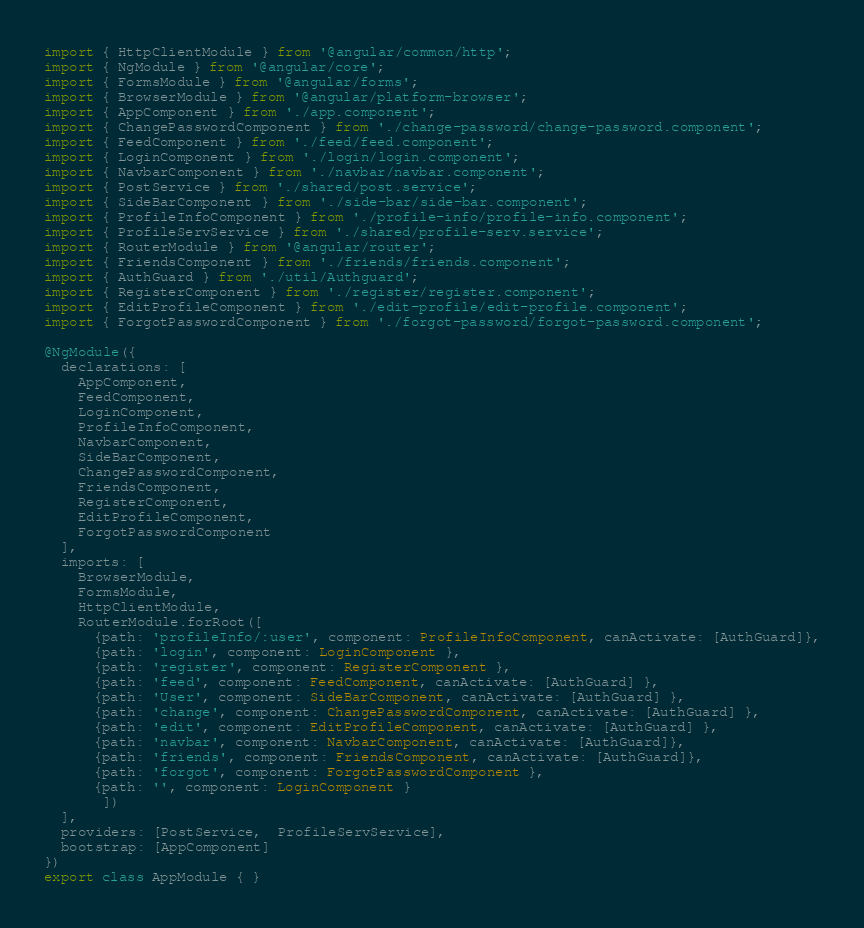<code> <loc_0><loc_0><loc_500><loc_500><_TypeScript_>import { HttpClientModule } from '@angular/common/http';
import { NgModule } from '@angular/core';
import { FormsModule } from '@angular/forms';
import { BrowserModule } from '@angular/platform-browser';
import { AppComponent } from './app.component';
import { ChangePasswordComponent } from './change-password/change-password.component';
import { FeedComponent } from './feed/feed.component';
import { LoginComponent } from './login/login.component';
import { NavbarComponent } from './navbar/navbar.component';
import { PostService } from './shared/post.service';
import { SideBarComponent } from './side-bar/side-bar.component';
import { ProfileInfoComponent } from './profile-info/profile-info.component';
import { ProfileServService } from './shared/profile-serv.service';
import { RouterModule } from '@angular/router';
import { FriendsComponent } from './friends/friends.component';
import { AuthGuard } from './util/Authguard';
import { RegisterComponent } from './register/register.component';
import { EditProfileComponent } from './edit-profile/edit-profile.component';
import { ForgotPasswordComponent } from './forgot-password/forgot-password.component';

@NgModule({
  declarations: [
    AppComponent,
    FeedComponent,
    LoginComponent,
    ProfileInfoComponent,
    NavbarComponent,
    SideBarComponent,
    ChangePasswordComponent,
    FriendsComponent,
    RegisterComponent,
    EditProfileComponent,
    ForgotPasswordComponent
  ],
  imports: [
    BrowserModule,
    FormsModule,
    HttpClientModule,
    RouterModule.forRoot([
      {path: 'profileInfo/:user', component: ProfileInfoComponent, canActivate: [AuthGuard]},
      {path: 'login', component: LoginComponent },
      {path: 'register', component: RegisterComponent },
      {path: 'feed', component: FeedComponent, canActivate: [AuthGuard] },
      {path: 'User', component: SideBarComponent, canActivate: [AuthGuard] },
      {path: 'change', component: ChangePasswordComponent, canActivate: [AuthGuard] },
      {path: 'edit', component: EditProfileComponent, canActivate: [AuthGuard] },
      {path: 'navbar', component: NavbarComponent, canActivate: [AuthGuard]},
      {path: 'friends', component: FriendsComponent, canActivate: [AuthGuard]},
      {path: 'forgot', component: ForgotPasswordComponent },
      {path: '', component: LoginComponent }
       ])
  ],
  providers: [PostService,  ProfileServService],
  bootstrap: [AppComponent]
})
export class AppModule { }
</code> 